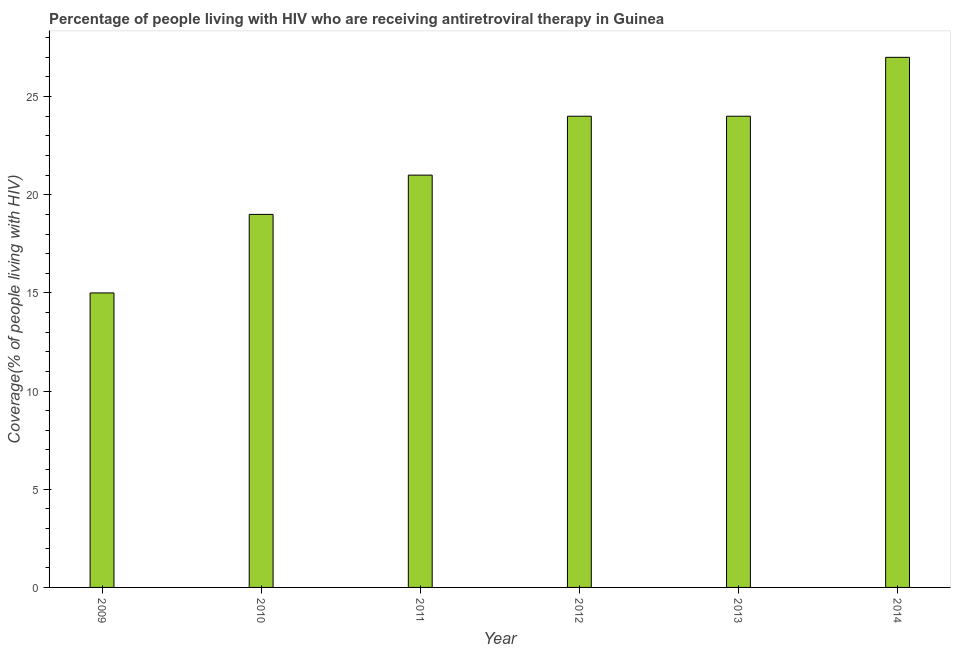What is the title of the graph?
Offer a terse response. Percentage of people living with HIV who are receiving antiretroviral therapy in Guinea. What is the label or title of the Y-axis?
Offer a terse response. Coverage(% of people living with HIV). Across all years, what is the minimum antiretroviral therapy coverage?
Offer a terse response. 15. In which year was the antiretroviral therapy coverage maximum?
Give a very brief answer. 2014. In which year was the antiretroviral therapy coverage minimum?
Your answer should be very brief. 2009. What is the sum of the antiretroviral therapy coverage?
Offer a very short reply. 130. What is the difference between the antiretroviral therapy coverage in 2013 and 2014?
Give a very brief answer. -3. What is the median antiretroviral therapy coverage?
Make the answer very short. 22.5. What is the ratio of the antiretroviral therapy coverage in 2010 to that in 2013?
Provide a succinct answer. 0.79. What is the difference between the highest and the second highest antiretroviral therapy coverage?
Give a very brief answer. 3. Is the sum of the antiretroviral therapy coverage in 2009 and 2010 greater than the maximum antiretroviral therapy coverage across all years?
Your response must be concise. Yes. How many bars are there?
Keep it short and to the point. 6. Are all the bars in the graph horizontal?
Provide a short and direct response. No. How many years are there in the graph?
Keep it short and to the point. 6. What is the difference between two consecutive major ticks on the Y-axis?
Your response must be concise. 5. What is the Coverage(% of people living with HIV) in 2011?
Offer a terse response. 21. What is the Coverage(% of people living with HIV) in 2012?
Offer a terse response. 24. What is the Coverage(% of people living with HIV) of 2013?
Your answer should be very brief. 24. What is the difference between the Coverage(% of people living with HIV) in 2009 and 2010?
Make the answer very short. -4. What is the difference between the Coverage(% of people living with HIV) in 2010 and 2013?
Your response must be concise. -5. What is the difference between the Coverage(% of people living with HIV) in 2010 and 2014?
Give a very brief answer. -8. What is the difference between the Coverage(% of people living with HIV) in 2012 and 2013?
Keep it short and to the point. 0. What is the difference between the Coverage(% of people living with HIV) in 2013 and 2014?
Offer a terse response. -3. What is the ratio of the Coverage(% of people living with HIV) in 2009 to that in 2010?
Provide a succinct answer. 0.79. What is the ratio of the Coverage(% of people living with HIV) in 2009 to that in 2011?
Make the answer very short. 0.71. What is the ratio of the Coverage(% of people living with HIV) in 2009 to that in 2012?
Your answer should be compact. 0.62. What is the ratio of the Coverage(% of people living with HIV) in 2009 to that in 2014?
Your answer should be very brief. 0.56. What is the ratio of the Coverage(% of people living with HIV) in 2010 to that in 2011?
Give a very brief answer. 0.91. What is the ratio of the Coverage(% of people living with HIV) in 2010 to that in 2012?
Offer a terse response. 0.79. What is the ratio of the Coverage(% of people living with HIV) in 2010 to that in 2013?
Offer a very short reply. 0.79. What is the ratio of the Coverage(% of people living with HIV) in 2010 to that in 2014?
Offer a very short reply. 0.7. What is the ratio of the Coverage(% of people living with HIV) in 2011 to that in 2013?
Provide a short and direct response. 0.88. What is the ratio of the Coverage(% of people living with HIV) in 2011 to that in 2014?
Make the answer very short. 0.78. What is the ratio of the Coverage(% of people living with HIV) in 2012 to that in 2013?
Your answer should be compact. 1. What is the ratio of the Coverage(% of people living with HIV) in 2012 to that in 2014?
Your answer should be compact. 0.89. What is the ratio of the Coverage(% of people living with HIV) in 2013 to that in 2014?
Give a very brief answer. 0.89. 